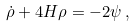<formula> <loc_0><loc_0><loc_500><loc_500>\dot { \rho } + 4 H \rho = - 2 \psi \, ,</formula> 